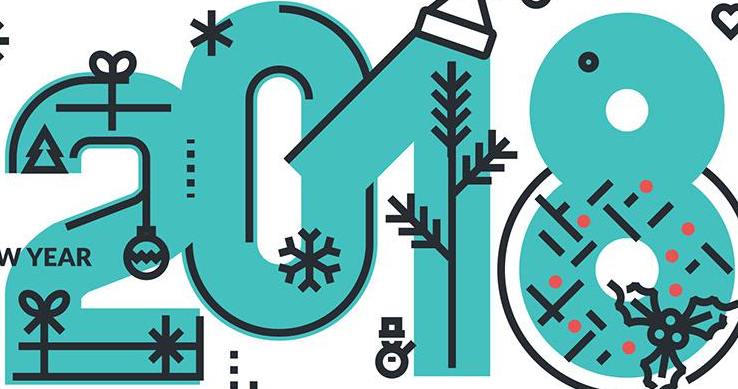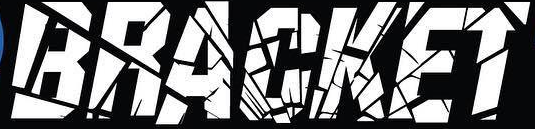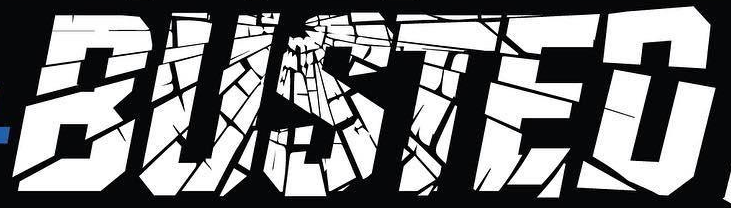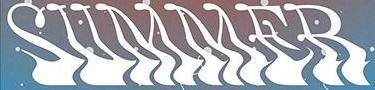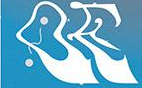Read the text from these images in sequence, separated by a semicolon. 2018; BRACKET; BUSTED; SUMMER; OE 